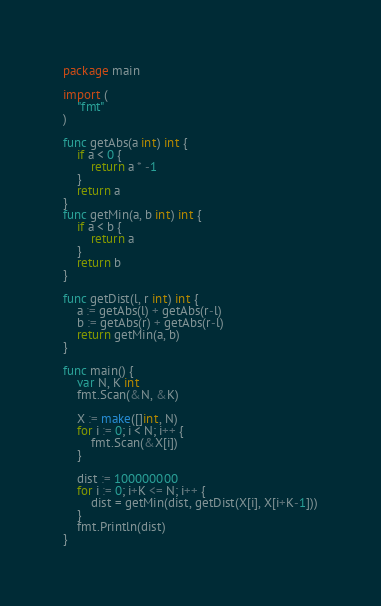Convert code to text. <code><loc_0><loc_0><loc_500><loc_500><_Go_>package main

import (
	"fmt"
)

func getAbs(a int) int {
	if a < 0 {
		return a * -1
	}
	return a
}
func getMin(a, b int) int {
	if a < b {
		return a
	}
	return b
}

func getDist(l, r int) int {
	a := getAbs(l) + getAbs(r-l)
	b := getAbs(r) + getAbs(r-l)
	return getMin(a, b)
}

func main() {
	var N, K int
	fmt.Scan(&N, &K)

	X := make([]int, N)
	for i := 0; i < N; i++ {
		fmt.Scan(&X[i])
	}

	dist := 100000000
	for i := 0; i+K <= N; i++ {
		dist = getMin(dist, getDist(X[i], X[i+K-1]))
	}
	fmt.Println(dist)
}
</code> 